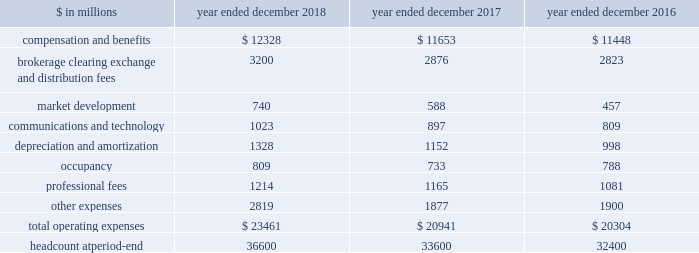The goldman sachs group , inc .
And subsidiaries management 2019s discussion and analysis 2018 versus 2017 .
Provision for credit losses in the consolidated statements of earnings was $ 674 million for 2018 , compared with $ 657 million for 2017 , as the higher provision for credit losses primarily related to consumer loan growth in 2018 was partially offset by an impairment of approximately $ 130 million on a secured loan in 2017 .
2017 versus 2016 .
Provision for credit losses in the consolidated statements of earnings was $ 657 million for 2017 , compared with $ 182 million for 2016 , reflecting an increase in impairments , which included an impairment of approximately $ 130 million on a secured loan in 2017 , and higher provision for credit losses primarily related to consumer loan growth .
Operating expenses our operating expenses are primarily influenced by compensation , headcount and levels of business activity .
Compensation and benefits includes salaries , discretionary compensation , amortization of equity awards and other items such as benefits .
Discretionary compensation is significantly impacted by , among other factors , the level of net revenues , overall financial performance , prevailing labor markets , business mix , the structure of our share-based compensation programs and the external environment .
In addition , see 201cuse of estimates 201d for further information about expenses that may arise from litigation and regulatory proceedings .
The table below presents operating expenses by line item and headcount. .
In the table above , the following reclassifications have been made to previously reported amounts to conform to the current presentation : 2030 regulatory-related fees that are paid to exchanges are now reported in brokerage , clearing , exchange and distribution fees .
Previously such amounts were reported in other expenses .
2030 headcount consists of our employees , and excludes consultants and temporary staff previously reported as part of total staff .
As a result , expenses related to these consultants and temporary staff are now reported in professional fees .
Previously such amounts were reported in compensation and benefits expenses .
2018 versus 2017 .
Operating expenses in the consolidated statements of earnings were $ 23.46 billion for 2018 , 12% ( 12 % ) higher than 2017 .
Our efficiency ratio ( total operating expenses divided by total net revenues ) for 2018 was 64.1% ( 64.1 % ) , compared with 64.0% ( 64.0 % ) for 2017 .
The increase in operating expenses compared with 2017 was primarily due to higher compensation and benefits expenses , reflecting improved operating performance , and significantly higher net provisions for litigation and regulatory proceedings .
Brokerage , clearing , exchange and distribution fees were also higher , reflecting an increase in activity levels , and technology expenses increased , reflecting higher expenses related to computing services .
In addition , expenses related to consolidated investments and our digital lending and deposit platform increased , with the increases primarily in depreciation and amortization expenses , market development expenses and other expenses .
The increase compared with 2017 also included $ 297 million related to the recently adopted revenue recognition standard .
See note 3 to the consolidated financial statements for further information about asu no .
2014-09 , 201crevenue from contracts with customers ( topic 606 ) . 201d net provisions for litigation and regulatory proceedings for 2018 were $ 844 million compared with $ 188 million for 2017 .
2018 included a $ 132 million charitable contribution to goldman sachs gives , our donor-advised fund .
Compensation was reduced to fund this charitable contribution to goldman sachs gives .
We ask our participating managing directors to make recommendations regarding potential charitable recipients for this contribution .
As of december 2018 , headcount increased 9% ( 9 % ) compared with december 2017 , reflecting an increase in technology professionals and investments in new business initiatives .
2017 versus 2016 .
Operating expenses in the consolidated statements of earnings were $ 20.94 billion for 2017 , 3% ( 3 % ) higher than 2016 .
Our efficiency ratio for 2017 was 64.0% ( 64.0 % ) compared with 65.9% ( 65.9 % ) for 2016 .
The increase in operating expenses compared with 2016 was primarily driven by slightly higher compensation and benefits expenses and our investments to fund growth .
Higher expenses related to consolidated investments and our digital lending and deposit platform were primarily included in depreciation and amortization expenses , market development expenses and other expenses .
In addition , technology expenses increased , reflecting higher expenses related to cloud-based services and software depreciation , and professional fees increased , primarily related to consulting costs .
These increases were partially offset by lower net provisions for litigation and regulatory proceedings , and lower occupancy expenses ( primarily related to exit costs in 2016 ) .
54 goldman sachs 2018 form 10-k .
What is the growth rate in operating expenses in 2017? 
Computations: ((20941 - 20304) / 20304)
Answer: 0.03137. 